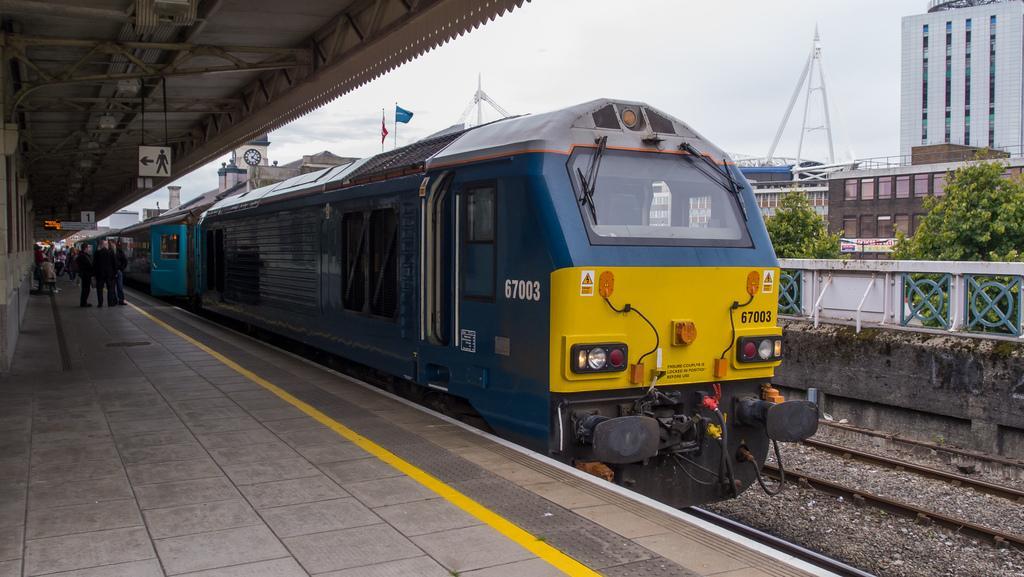Please provide a concise description of this image. Here I can see a train on the railway track. On the left side I can see many people are standing on the platform. On the right side there is a wall and railing. In the background, I can see the trees and buildings. At the top of the image I can see the sky. 